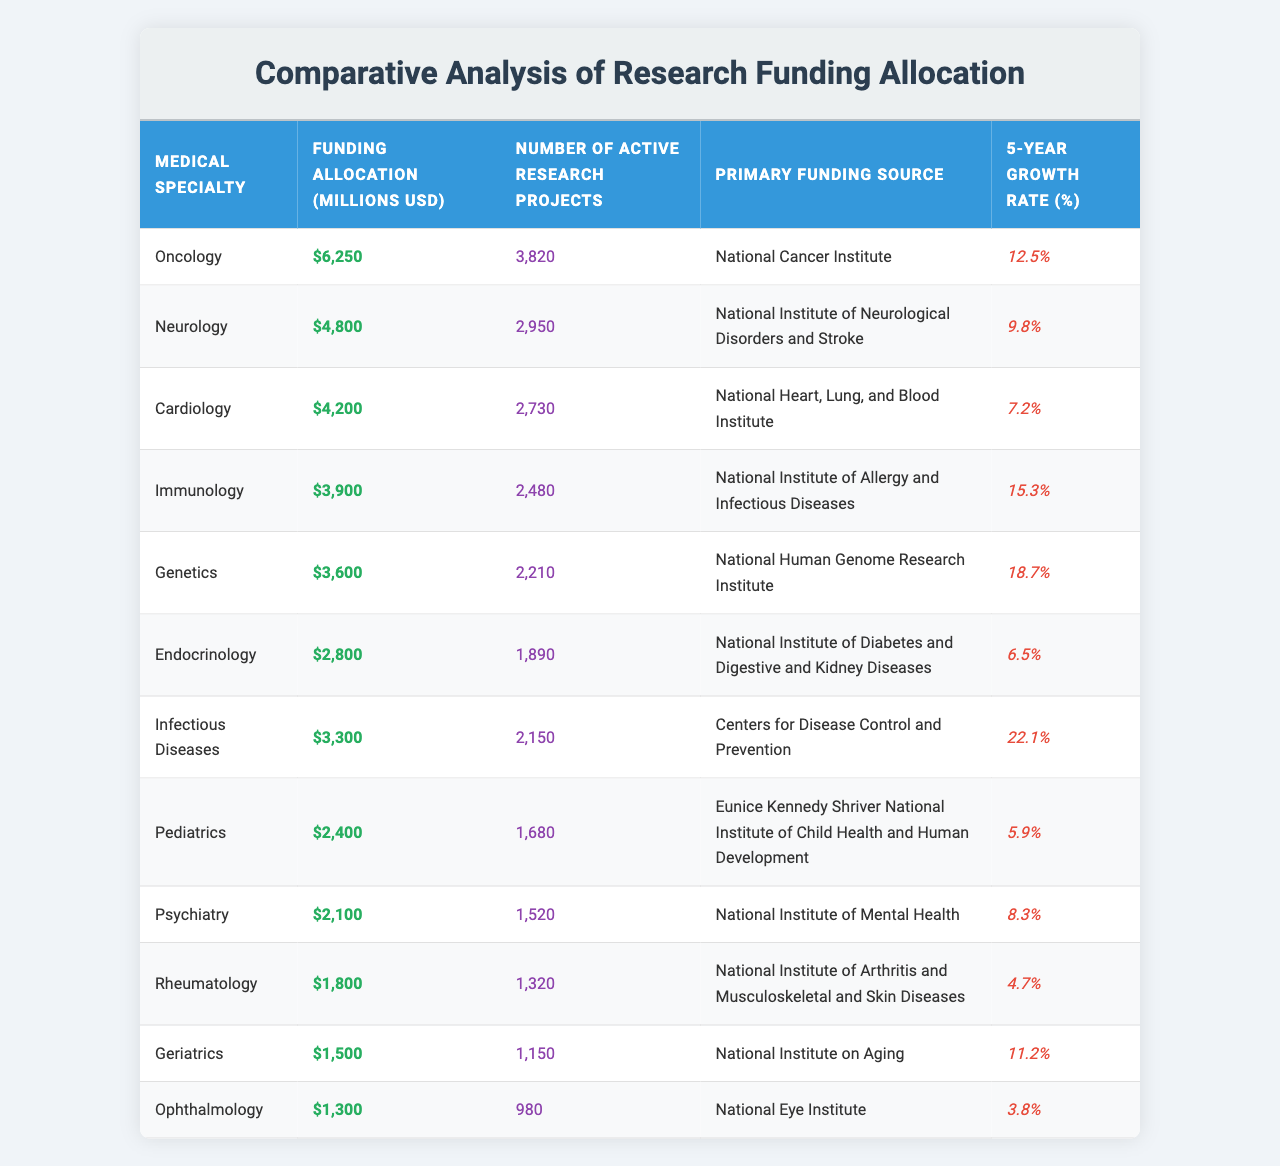What is the medical specialty with the highest funding allocation? By examining the "Funding Allocation" column, we can see that Oncology has the highest amount listed, which is 6250 million USD.
Answer: Oncology How many active research projects are there in Neurology? Looking under the "Number of Active Research Projects" column for Neurology, the value is 2950 projects.
Answer: 2950 Which medical specialty has the lowest funding allocation? By reviewing the values in the "Funding Allocation" column, Ophthalmology has the lowest amount at 1300 million USD.
Answer: Ophthalmology What is the growth rate for Infectious Diseases? The "5-Year Growth Rate (%)" column shows that Infectious Diseases has a growth rate of 22.1%.
Answer: 22.1% Which funding source is associated with Cardiology? Referring to the "Primary Funding Source" column, the funding source for Cardiology is the National Heart, Lung, and Blood Institute.
Answer: National Heart, Lung, and Blood Institute What is the total funding allocation for the top three specialties? Adding the funding allocations for Oncology (6250), Neurology (4800), and Cardiology (4200): 6250 + 4800 + 4200 = 15250 million USD for the top three specialties.
Answer: 15250 million USD Is the growth rate for Genetics higher than that for Rheumatology? Comparing the "5-Year Growth Rate (%)" for Genetics (18.7%) and Rheumatology (4.7%), Genetics has a higher rate.
Answer: Yes Which specialty has more active research projects: Immunology or Endocrinology? Immunology has 2480 projects while Endocrinology has 1890 projects, so Immunology has more projects.
Answer: Immunology What is the average funding allocation among all specialties? Summing the funding allocations: 6250 + 4800 + 4200 + 3900 + 3600 + 2800 + 3300 + 2400 + 2100 + 1800 + 1500 + 1300 = 23750 million USD. Dividing by 12 specialties gives an average of 1979.17 million USD.
Answer: 1979.17 million USD Which specialty has a funding growth rate of more than 15%? By identifying the growth rates listed, Infectious Diseases (22.1%), Immunology (15.3%), and Genetics (18.7%) exceed 15%.
Answer: Infectious Diseases, Immunology, Genetics What is the difference in funding allocation between Oncology and Pediatrics? Subtracting the funding allocation for Pediatrics (2400 million USD) from Oncology (6250 million USD), we find the difference is 6250 - 2400 = 3850 million USD.
Answer: 3850 million USD 